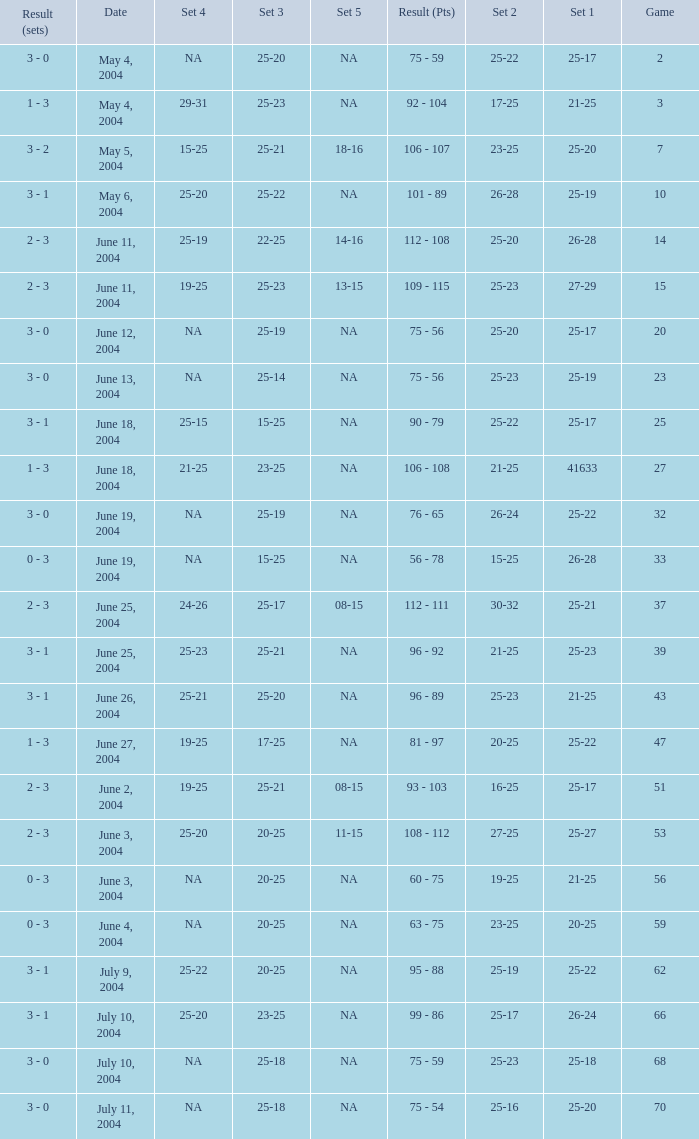Could you help me parse every detail presented in this table? {'header': ['Result (sets)', 'Date', 'Set 4', 'Set 3', 'Set 5', 'Result (Pts)', 'Set 2', 'Set 1', 'Game'], 'rows': [['3 - 0', 'May 4, 2004', 'NA', '25-20', 'NA', '75 - 59', '25-22', '25-17', '2'], ['1 - 3', 'May 4, 2004', '29-31', '25-23', 'NA', '92 - 104', '17-25', '21-25', '3'], ['3 - 2', 'May 5, 2004', '15-25', '25-21', '18-16', '106 - 107', '23-25', '25-20', '7'], ['3 - 1', 'May 6, 2004', '25-20', '25-22', 'NA', '101 - 89', '26-28', '25-19', '10'], ['2 - 3', 'June 11, 2004', '25-19', '22-25', '14-16', '112 - 108', '25-20', '26-28', '14'], ['2 - 3', 'June 11, 2004', '19-25', '25-23', '13-15', '109 - 115', '25-23', '27-29', '15'], ['3 - 0', 'June 12, 2004', 'NA', '25-19', 'NA', '75 - 56', '25-20', '25-17', '20'], ['3 - 0', 'June 13, 2004', 'NA', '25-14', 'NA', '75 - 56', '25-23', '25-19', '23'], ['3 - 1', 'June 18, 2004', '25-15', '15-25', 'NA', '90 - 79', '25-22', '25-17', '25'], ['1 - 3', 'June 18, 2004', '21-25', '23-25', 'NA', '106 - 108', '21-25', '41633', '27'], ['3 - 0', 'June 19, 2004', 'NA', '25-19', 'NA', '76 - 65', '26-24', '25-22', '32'], ['0 - 3', 'June 19, 2004', 'NA', '15-25', 'NA', '56 - 78', '15-25', '26-28', '33'], ['2 - 3', 'June 25, 2004', '24-26', '25-17', '08-15', '112 - 111', '30-32', '25-21', '37'], ['3 - 1', 'June 25, 2004', '25-23', '25-21', 'NA', '96 - 92', '21-25', '25-23', '39'], ['3 - 1', 'June 26, 2004', '25-21', '25-20', 'NA', '96 - 89', '25-23', '21-25', '43'], ['1 - 3', 'June 27, 2004', '19-25', '17-25', 'NA', '81 - 97', '20-25', '25-22', '47'], ['2 - 3', 'June 2, 2004', '19-25', '25-21', '08-15', '93 - 103', '16-25', '25-17', '51'], ['2 - 3', 'June 3, 2004', '25-20', '20-25', '11-15', '108 - 112', '27-25', '25-27', '53'], ['0 - 3', 'June 3, 2004', 'NA', '20-25', 'NA', '60 - 75', '19-25', '21-25', '56'], ['0 - 3', 'June 4, 2004', 'NA', '20-25', 'NA', '63 - 75', '23-25', '20-25', '59'], ['3 - 1', 'July 9, 2004', '25-22', '20-25', 'NA', '95 - 88', '25-19', '25-22', '62'], ['3 - 1', 'July 10, 2004', '25-20', '23-25', 'NA', '99 - 86', '25-17', '26-24', '66'], ['3 - 0', 'July 10, 2004', 'NA', '25-18', 'NA', '75 - 59', '25-23', '25-18', '68'], ['3 - 0', 'July 11, 2004', 'NA', '25-18', 'NA', '75 - 54', '25-16', '25-20', '70']]} What is the result of the game with a set 1 of 26-24? 99 - 86. 